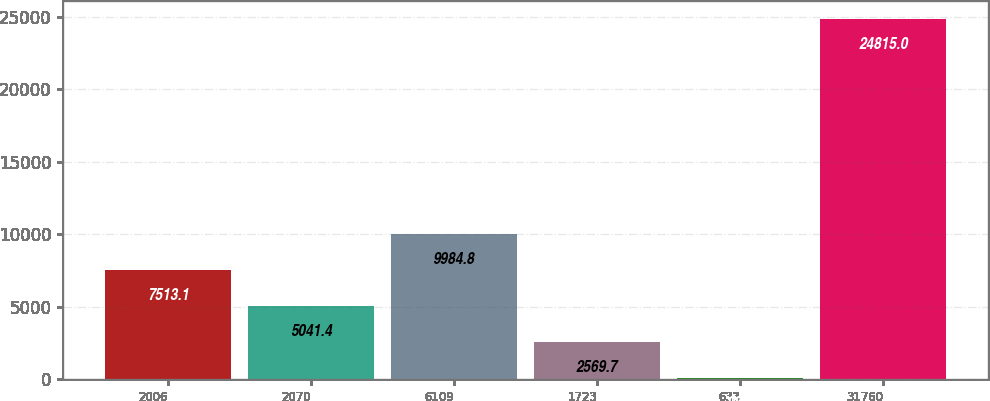Convert chart. <chart><loc_0><loc_0><loc_500><loc_500><bar_chart><fcel>2006<fcel>2070<fcel>6109<fcel>1723<fcel>633<fcel>31760<nl><fcel>7513.1<fcel>5041.4<fcel>9984.8<fcel>2569.7<fcel>98<fcel>24815<nl></chart> 